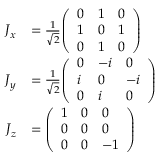<formula> <loc_0><loc_0><loc_500><loc_500>{ \begin{array} { r l } { { J } _ { x } } & { = { \frac { 1 } { \sqrt { 2 } } } { \left ( \begin{array} { l l l } { 0 } & { 1 } & { 0 } \\ { 1 } & { 0 } & { 1 } \\ { 0 } & { 1 } & { 0 } \end{array} \right ) } } \\ { { J } _ { y } } & { = { \frac { 1 } { \sqrt { 2 } } } { \left ( \begin{array} { l l l } { 0 } & { - i } & { 0 } \\ { i } & { 0 } & { - i } \\ { 0 } & { i } & { 0 } \end{array} \right ) } } \\ { { J } _ { z } } & { = { \left ( \begin{array} { l l l } { 1 } & { 0 } & { 0 } \\ { 0 } & { 0 } & { 0 } \\ { 0 } & { 0 } & { - 1 } \end{array} \right ) } } \end{array} }</formula> 